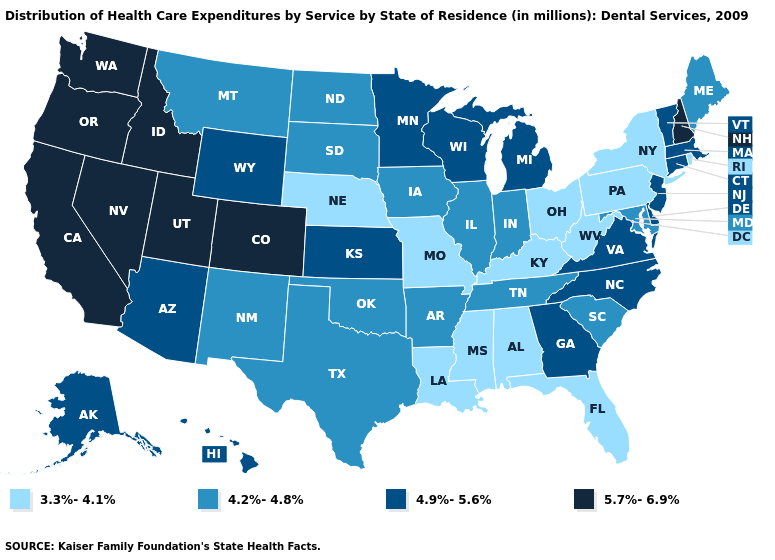What is the highest value in the USA?
Write a very short answer. 5.7%-6.9%. Which states have the highest value in the USA?
Write a very short answer. California, Colorado, Idaho, Nevada, New Hampshire, Oregon, Utah, Washington. Which states have the lowest value in the USA?
Short answer required. Alabama, Florida, Kentucky, Louisiana, Mississippi, Missouri, Nebraska, New York, Ohio, Pennsylvania, Rhode Island, West Virginia. What is the value of Alaska?
Concise answer only. 4.9%-5.6%. What is the value of South Dakota?
Keep it brief. 4.2%-4.8%. What is the lowest value in the USA?
Keep it brief. 3.3%-4.1%. What is the value of Tennessee?
Write a very short answer. 4.2%-4.8%. Name the states that have a value in the range 3.3%-4.1%?
Short answer required. Alabama, Florida, Kentucky, Louisiana, Mississippi, Missouri, Nebraska, New York, Ohio, Pennsylvania, Rhode Island, West Virginia. Name the states that have a value in the range 3.3%-4.1%?
Keep it brief. Alabama, Florida, Kentucky, Louisiana, Mississippi, Missouri, Nebraska, New York, Ohio, Pennsylvania, Rhode Island, West Virginia. What is the value of Arkansas?
Be succinct. 4.2%-4.8%. What is the highest value in the USA?
Concise answer only. 5.7%-6.9%. Among the states that border Delaware , does New Jersey have the highest value?
Answer briefly. Yes. What is the lowest value in the USA?
Short answer required. 3.3%-4.1%. Which states have the highest value in the USA?
Short answer required. California, Colorado, Idaho, Nevada, New Hampshire, Oregon, Utah, Washington. Does Florida have the lowest value in the South?
Keep it brief. Yes. 